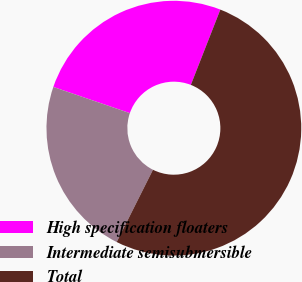Convert chart. <chart><loc_0><loc_0><loc_500><loc_500><pie_chart><fcel>High specification floaters<fcel>Intermediate semisubmersible<fcel>Total<nl><fcel>25.7%<fcel>22.84%<fcel>51.46%<nl></chart> 